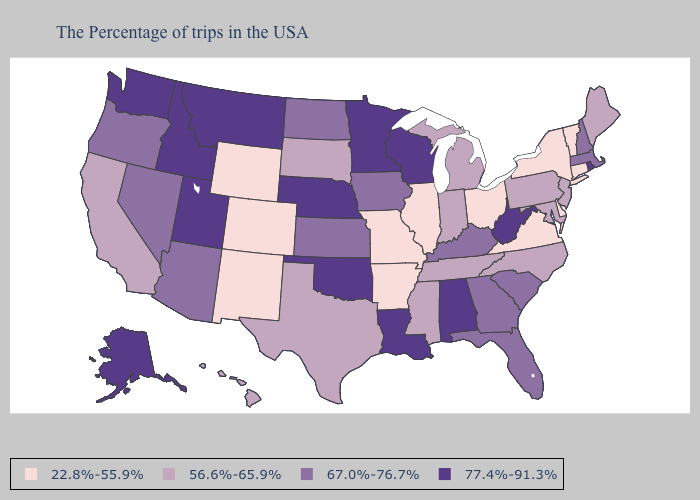What is the lowest value in the USA?
Be succinct. 22.8%-55.9%. What is the lowest value in the Northeast?
Write a very short answer. 22.8%-55.9%. What is the lowest value in the USA?
Concise answer only. 22.8%-55.9%. Among the states that border Pennsylvania , which have the highest value?
Concise answer only. West Virginia. Does Utah have the highest value in the West?
Give a very brief answer. Yes. Among the states that border Illinois , does Kentucky have the highest value?
Keep it brief. No. Does Washington have a higher value than Delaware?
Short answer required. Yes. Name the states that have a value in the range 22.8%-55.9%?
Give a very brief answer. Vermont, Connecticut, New York, Delaware, Virginia, Ohio, Illinois, Missouri, Arkansas, Wyoming, Colorado, New Mexico. Does South Carolina have the lowest value in the USA?
Give a very brief answer. No. Name the states that have a value in the range 22.8%-55.9%?
Quick response, please. Vermont, Connecticut, New York, Delaware, Virginia, Ohio, Illinois, Missouri, Arkansas, Wyoming, Colorado, New Mexico. What is the highest value in the Northeast ?
Short answer required. 77.4%-91.3%. Name the states that have a value in the range 77.4%-91.3%?
Concise answer only. Rhode Island, West Virginia, Alabama, Wisconsin, Louisiana, Minnesota, Nebraska, Oklahoma, Utah, Montana, Idaho, Washington, Alaska. Does Missouri have the lowest value in the USA?
Answer briefly. Yes. Name the states that have a value in the range 67.0%-76.7%?
Keep it brief. Massachusetts, New Hampshire, South Carolina, Florida, Georgia, Kentucky, Iowa, Kansas, North Dakota, Arizona, Nevada, Oregon. Is the legend a continuous bar?
Answer briefly. No. 